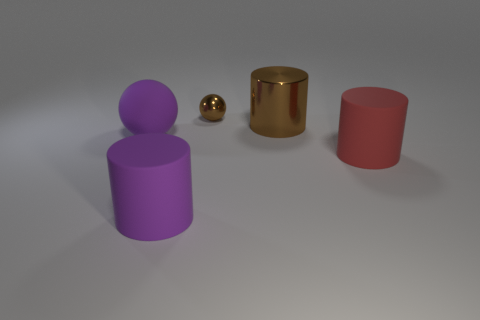What is the large red cylinder made of?
Your answer should be very brief. Rubber. There is a large metal cylinder; does it have the same color as the sphere behind the purple ball?
Provide a short and direct response. Yes. Is there any other thing that has the same size as the brown metal ball?
Keep it short and to the point. No. What is the size of the object that is both to the left of the large brown metallic object and behind the matte ball?
Your answer should be very brief. Small. The tiny brown thing that is made of the same material as the large brown object is what shape?
Ensure brevity in your answer.  Sphere. Do the small brown thing and the purple thing behind the red object have the same material?
Give a very brief answer. No. There is a object that is in front of the big red matte object; is there a large purple thing on the left side of it?
Provide a succinct answer. Yes. There is a brown thing that is the same shape as the large red rubber thing; what material is it?
Ensure brevity in your answer.  Metal. There is a purple thing in front of the purple ball; how many large purple cylinders are in front of it?
Keep it short and to the point. 0. How many objects are either tiny red spheres or objects to the left of the shiny sphere?
Make the answer very short. 2. 